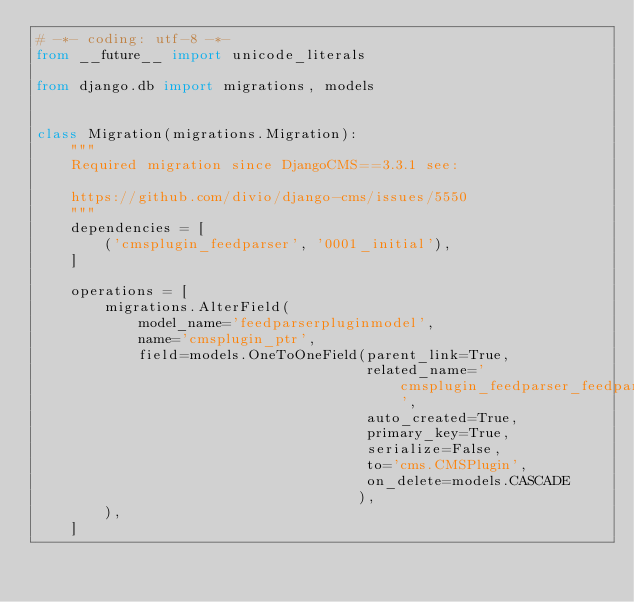Convert code to text. <code><loc_0><loc_0><loc_500><loc_500><_Python_># -*- coding: utf-8 -*-
from __future__ import unicode_literals

from django.db import migrations, models


class Migration(migrations.Migration):
    """
    Required migration since DjangoCMS==3.3.1 see:

    https://github.com/divio/django-cms/issues/5550
    """
    dependencies = [
        ('cmsplugin_feedparser', '0001_initial'),
    ]

    operations = [
        migrations.AlterField(
            model_name='feedparserpluginmodel',
            name='cmsplugin_ptr',
            field=models.OneToOneField(parent_link=True, 
                                       related_name='cmsplugin_feedparser_feedparserpluginmodel', 
                                       auto_created=True, 
                                       primary_key=True, 
                                       serialize=False, 
                                       to='cms.CMSPlugin',
                                       on_delete=models.CASCADE
                                      ),
        ),
    ]
</code> 